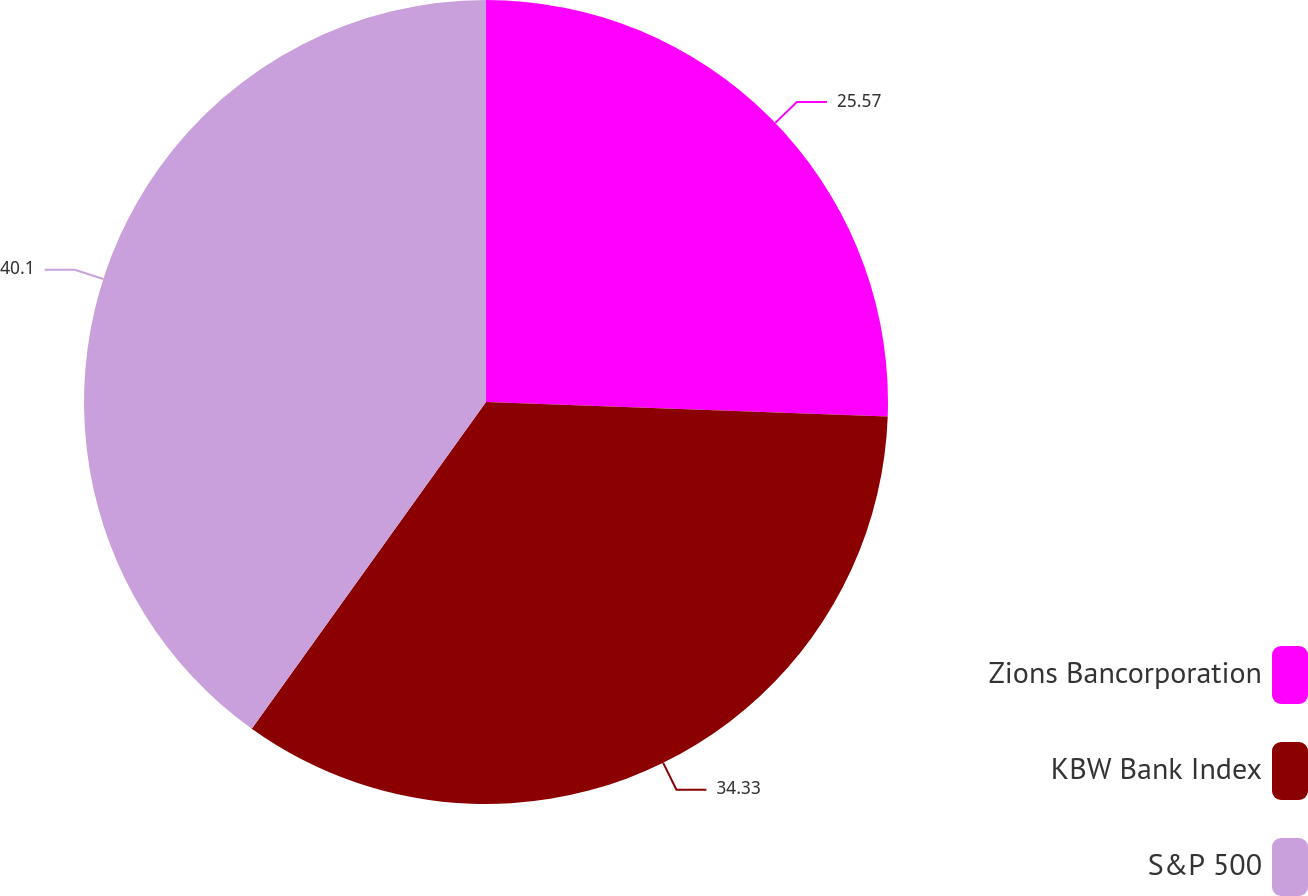Convert chart. <chart><loc_0><loc_0><loc_500><loc_500><pie_chart><fcel>Zions Bancorporation<fcel>KBW Bank Index<fcel>S&P 500<nl><fcel>25.57%<fcel>34.33%<fcel>40.1%<nl></chart> 